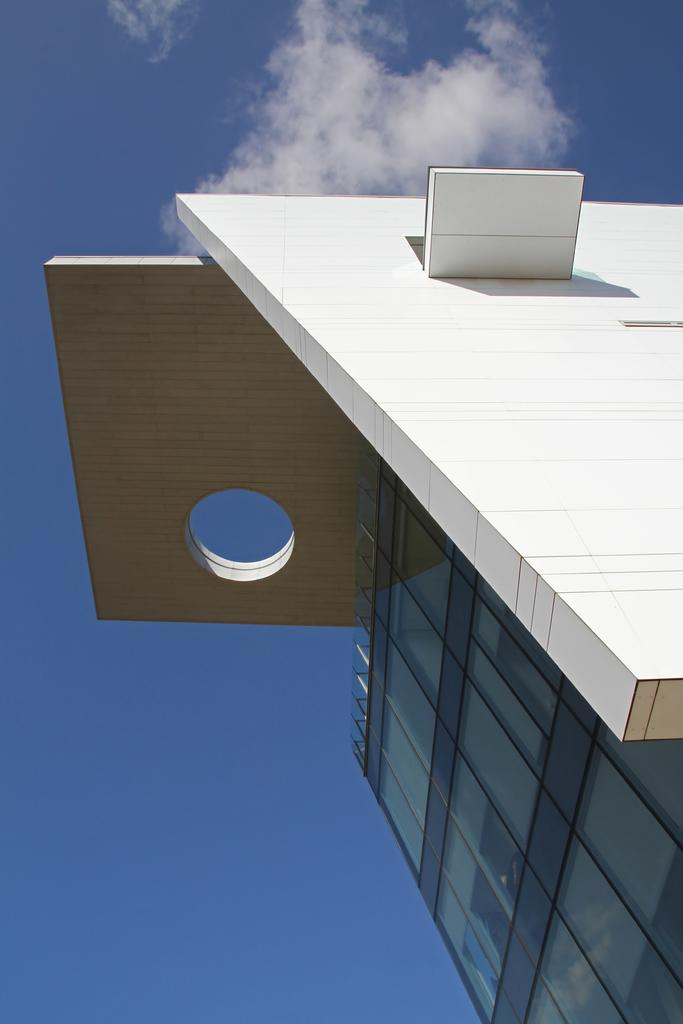What structure is located on the right side of the image? There is a building on the right side of the image. What type of wall can be seen in the image? There is a glass wall in the image. What is visible at the top of the image? The sky is visible at the top of the image. How many bananas are hanging from the glass wall in the image? There are no bananas present in the image. What type of love is depicted in the image? There is no depiction of love in the image; it features a building and a glass wall. 